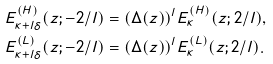<formula> <loc_0><loc_0><loc_500><loc_500>E _ { \kappa + l \delta } ^ { ( H ) } ( z ; - 2 / l ) & = ( \Delta ( z ) ) ^ { l } E ^ { ( H ) } _ { \kappa } ( z ; 2 / l ) , \\ E ^ { ( L ) } _ { \kappa + l \delta } ( z ; - 2 / l ) & = ( \Delta ( z ) ) ^ { l } E ^ { ( L ) } _ { \kappa } ( z ; 2 / l ) .</formula> 